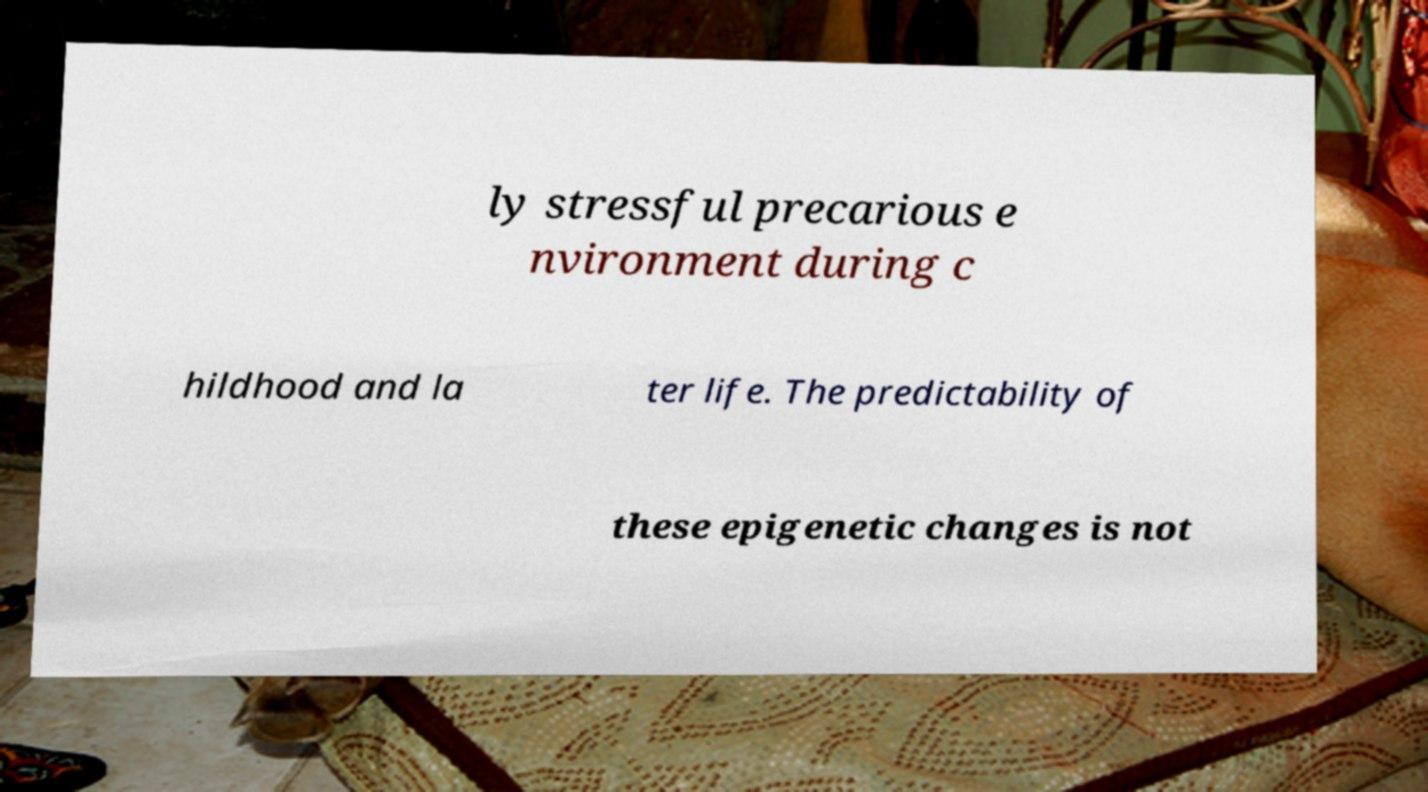What messages or text are displayed in this image? I need them in a readable, typed format. ly stressful precarious e nvironment during c hildhood and la ter life. The predictability of these epigenetic changes is not 